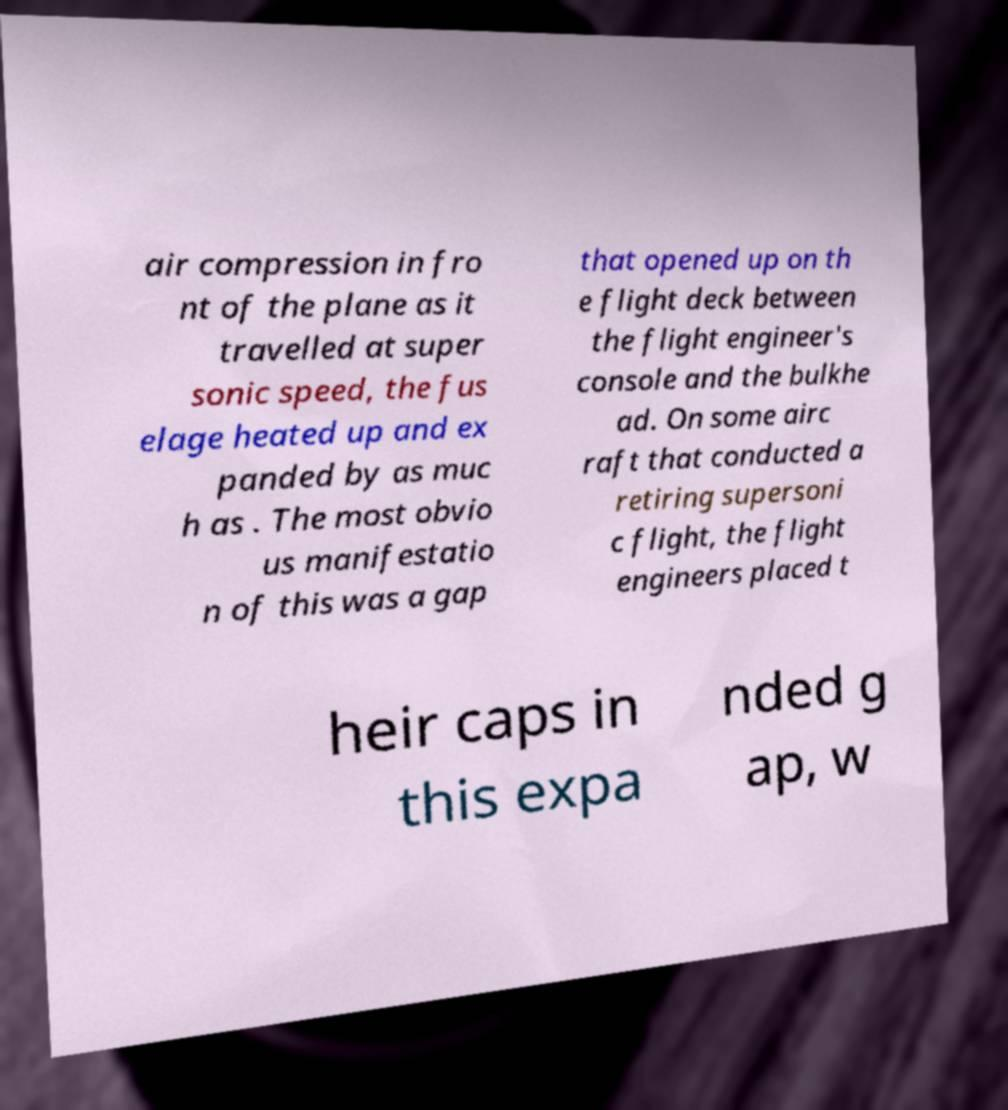Could you extract and type out the text from this image? air compression in fro nt of the plane as it travelled at super sonic speed, the fus elage heated up and ex panded by as muc h as . The most obvio us manifestatio n of this was a gap that opened up on th e flight deck between the flight engineer's console and the bulkhe ad. On some airc raft that conducted a retiring supersoni c flight, the flight engineers placed t heir caps in this expa nded g ap, w 